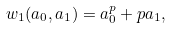Convert formula to latex. <formula><loc_0><loc_0><loc_500><loc_500>w _ { 1 } ( a _ { 0 } , a _ { 1 } ) = a _ { 0 } ^ { p } + p a _ { 1 } ,</formula> 